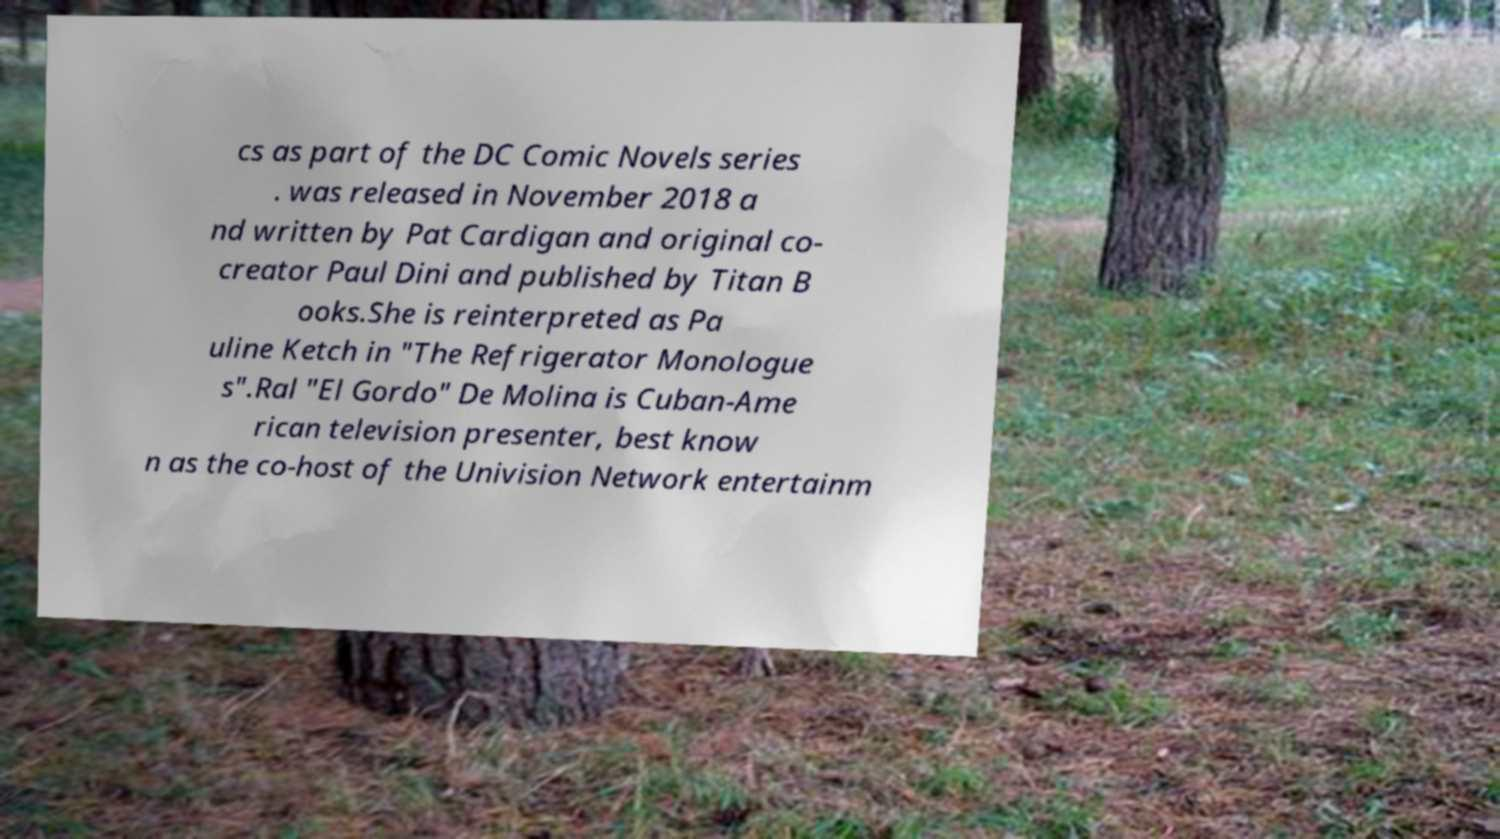What messages or text are displayed in this image? I need them in a readable, typed format. cs as part of the DC Comic Novels series . was released in November 2018 a nd written by Pat Cardigan and original co- creator Paul Dini and published by Titan B ooks.She is reinterpreted as Pa uline Ketch in "The Refrigerator Monologue s".Ral "El Gordo" De Molina is Cuban-Ame rican television presenter, best know n as the co-host of the Univision Network entertainm 